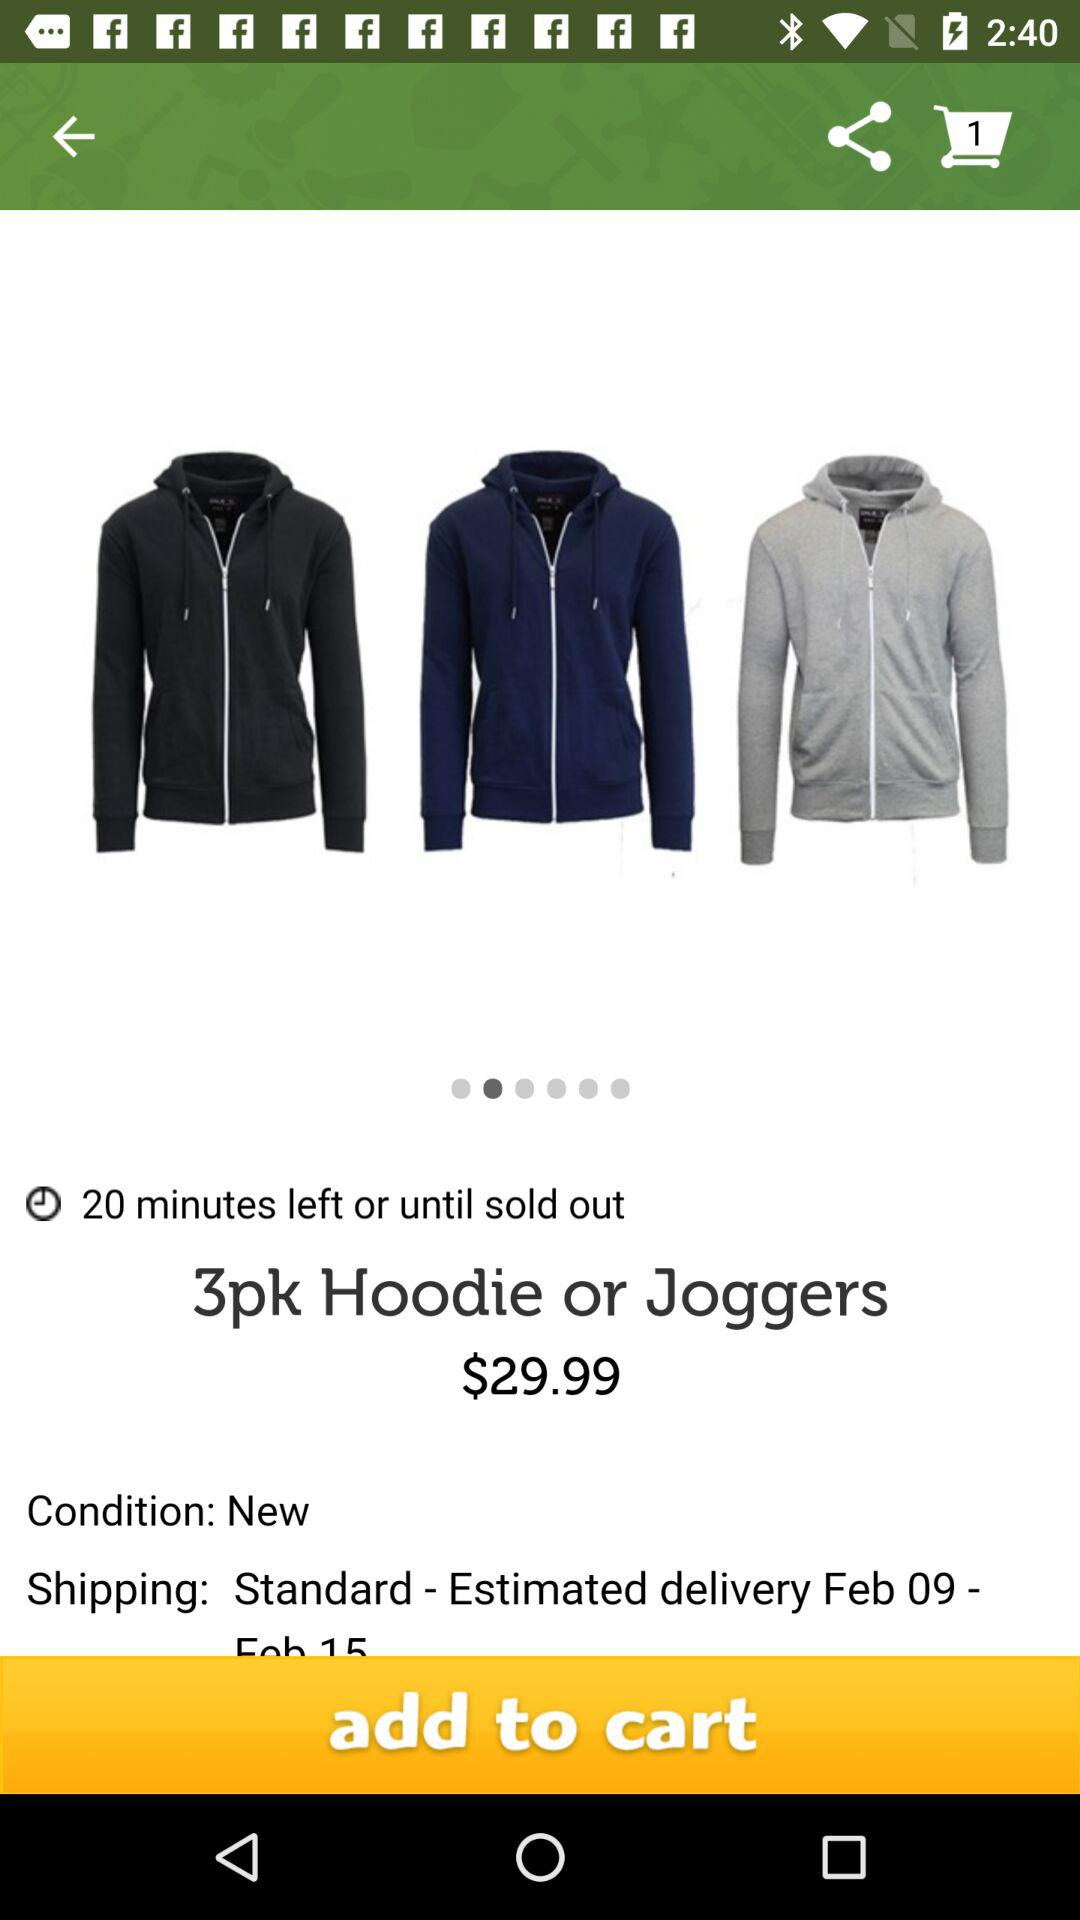What is the estimated delivery date? The estimated delivery date is from February 9 to February 15. 